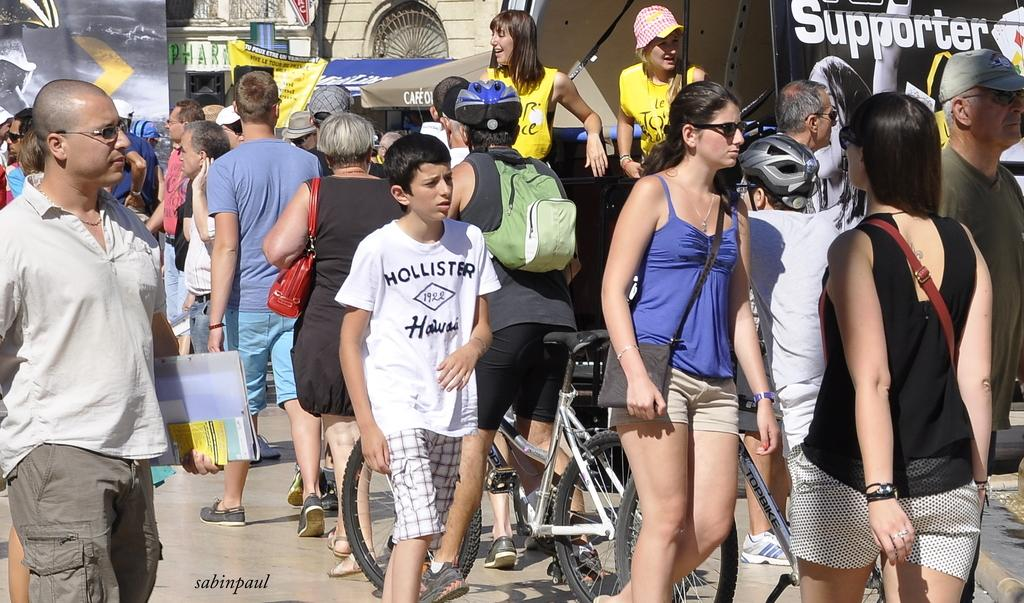What is happening in the image? There is a group of people in the image. What are the people doing in the image? The people are walking on a road. What type of vehicle are the people driving in the image? There is no vehicle present in the image; the people are walking on a road. 